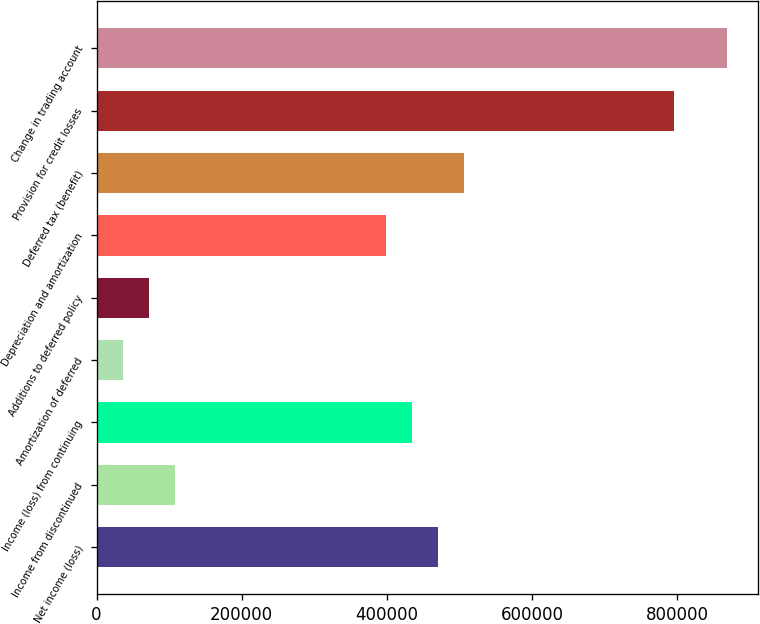Convert chart to OTSL. <chart><loc_0><loc_0><loc_500><loc_500><bar_chart><fcel>Net income (loss)<fcel>Income from discontinued<fcel>Income (loss) from continuing<fcel>Amortization of deferred<fcel>Additions to deferred policy<fcel>Depreciation and amortization<fcel>Deferred tax (benefit)<fcel>Provision for credit losses<fcel>Change in trading account<nl><fcel>470482<fcel>108655<fcel>434299<fcel>36289.7<fcel>72472.4<fcel>398117<fcel>506665<fcel>796126<fcel>868492<nl></chart> 